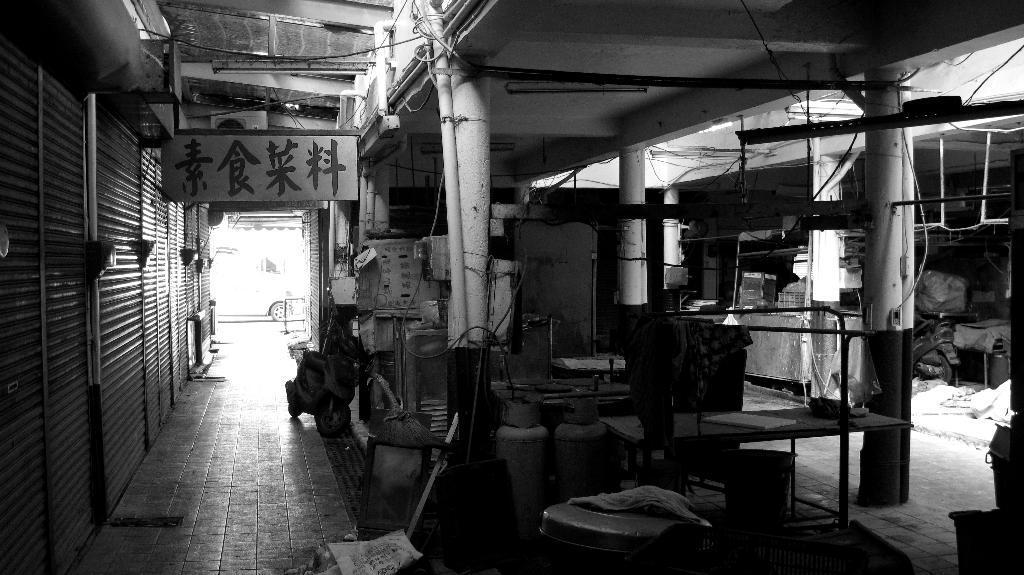Please provide a concise description of this image. In this picture there is a view of the storehouse. In the front there is a chair and pipe table. Behind we can see machines boxes. On the left side of the image there are some shop roller shutters. 